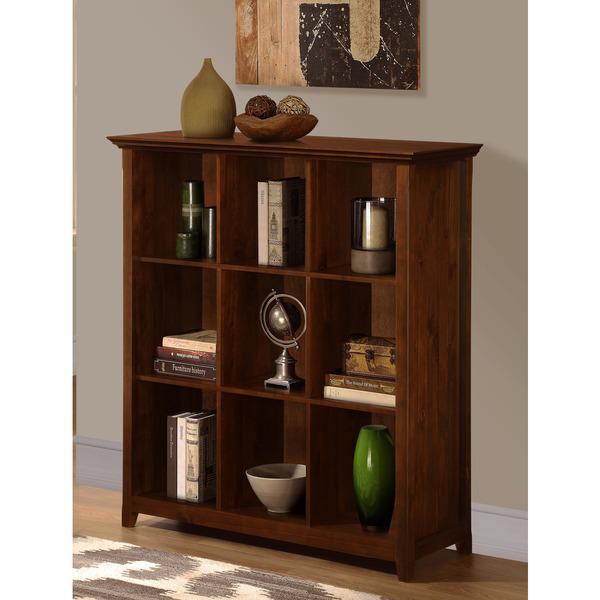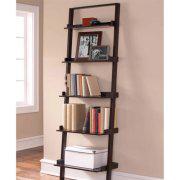The first image is the image on the left, the second image is the image on the right. Given the left and right images, does the statement "There is a window visible in one of the photos." hold true? Answer yes or no. Yes. The first image is the image on the left, the second image is the image on the right. Analyze the images presented: Is the assertion "An image of a brown bookshelf includes a ladder design of some type." valid? Answer yes or no. Yes. 